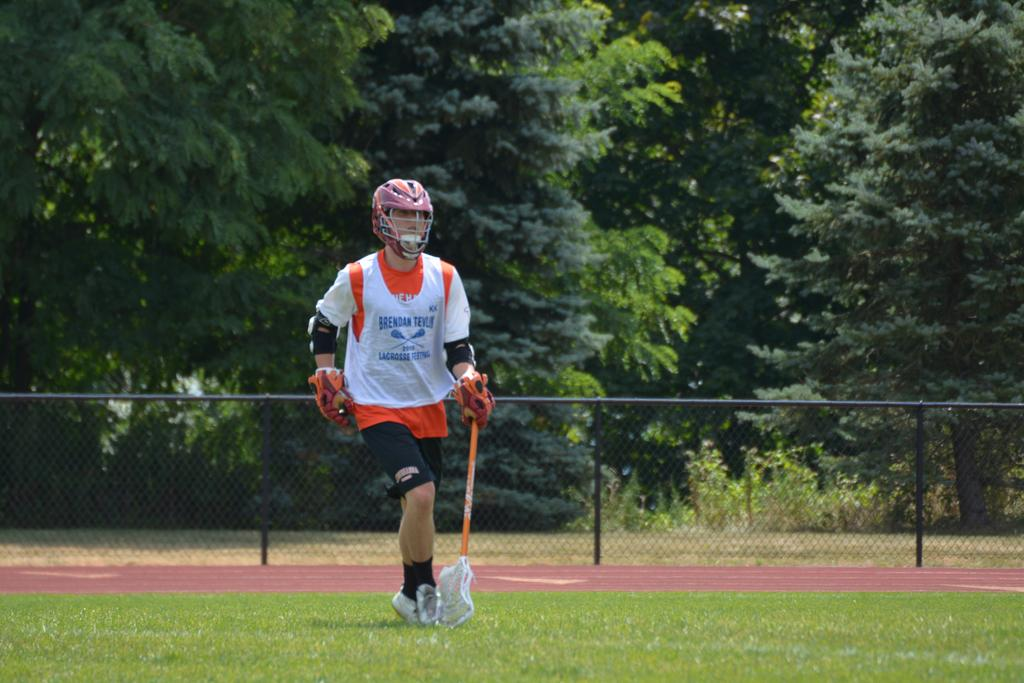<image>
Relay a brief, clear account of the picture shown. A lacrosse player named Brendan Teylor runs down the field holding his lacrosse stick 